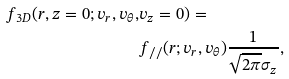<formula> <loc_0><loc_0><loc_500><loc_500>f _ { 3 D } ( r , z = 0 ; v _ { r } , v _ { \theta } , & v _ { z } = 0 ) = \\ & f _ { / / } ( r ; v _ { r } , v _ { \theta } ) \frac { 1 } { \sqrt { 2 \pi } \sigma _ { z } } ,</formula> 